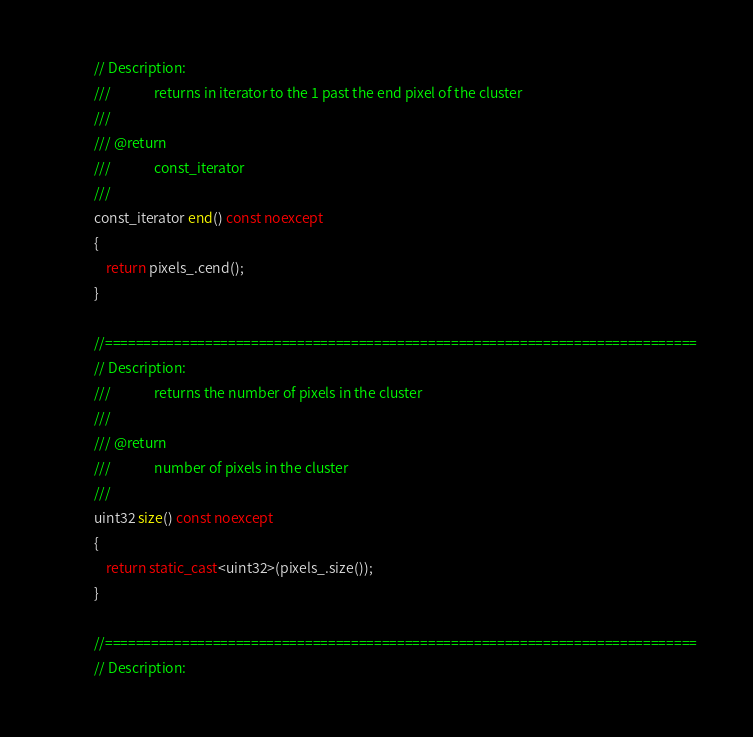<code> <loc_0><loc_0><loc_500><loc_500><_C++_>            // Description:
            ///              returns in iterator to the 1 past the end pixel of the cluster
            ///
            /// @return
            ///              const_iterator
            ///
            const_iterator end() const noexcept
            {
                return pixels_.cend();
            }

            //=============================================================================
            // Description:
            ///              returns the number of pixels in the cluster
            ///
            /// @return
            ///              number of pixels in the cluster
            ///
            uint32 size() const noexcept
            {
                return static_cast<uint32>(pixels_.size());
            }

            //=============================================================================
            // Description:</code> 